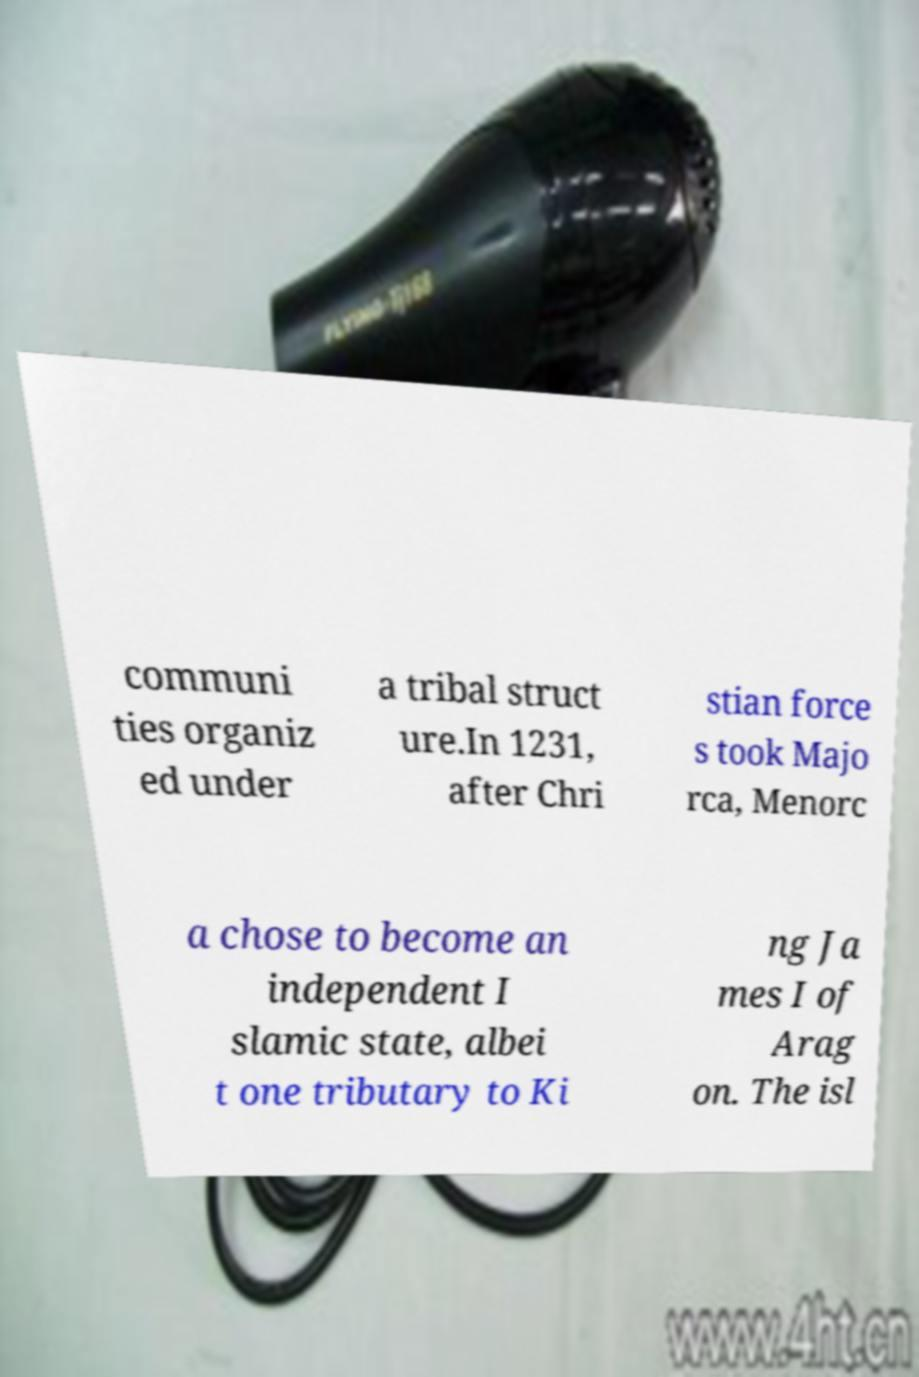Please identify and transcribe the text found in this image. communi ties organiz ed under a tribal struct ure.In 1231, after Chri stian force s took Majo rca, Menorc a chose to become an independent I slamic state, albei t one tributary to Ki ng Ja mes I of Arag on. The isl 